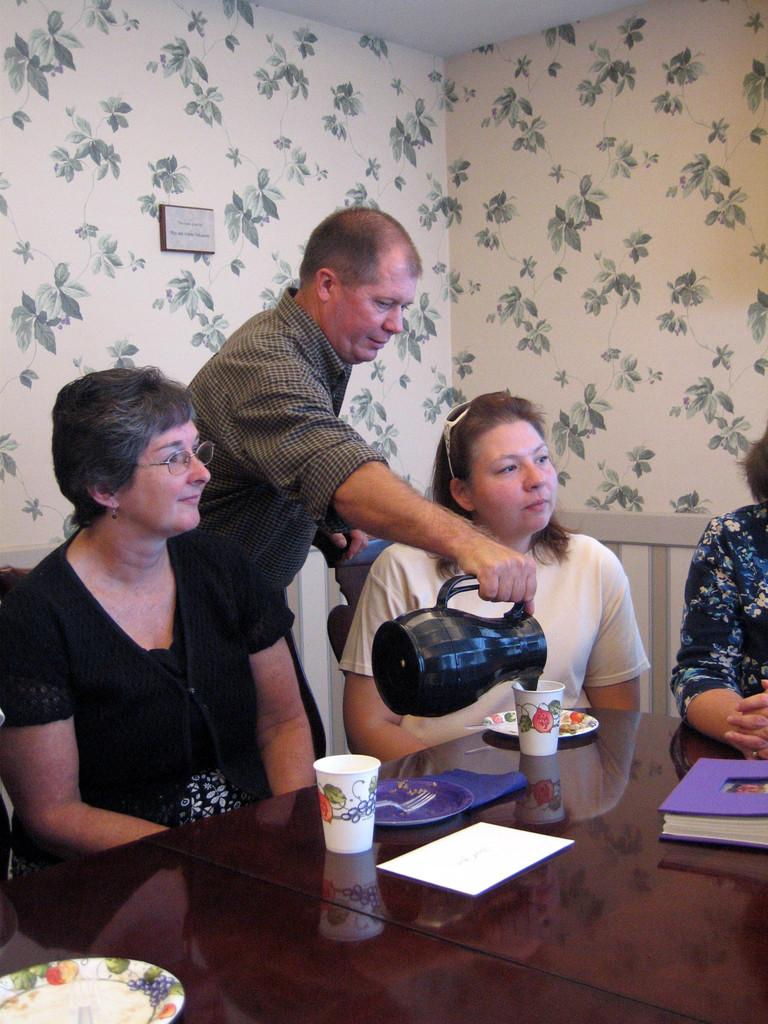How many women are in the image? There are three women in the image. What are the women doing in the image? The women are sitting on chairs. Is there anyone else in the image besides the women? Yes, there is a person standing in the image. What is the person doing in the image? The person is pouring water into a glass. What type of throne is the person sitting on in the image? There is no throne present in the image; the women are sitting on chairs, and the person is standing. How many people are attacking the women in the image? There is no attack or aggression depicted in the image; the women are sitting peacefully, and the person is pouring water into a glass. 